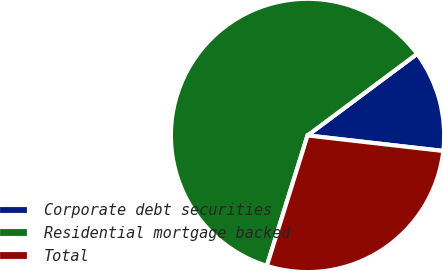Convert chart to OTSL. <chart><loc_0><loc_0><loc_500><loc_500><pie_chart><fcel>Corporate debt securities<fcel>Residential mortgage backed<fcel>Total<nl><fcel>12.0%<fcel>60.0%<fcel>28.0%<nl></chart> 